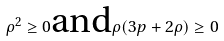Convert formula to latex. <formula><loc_0><loc_0><loc_500><loc_500>\rho ^ { 2 } \geq 0 \text {and} \rho ( 3 p + 2 \rho ) \geq 0</formula> 